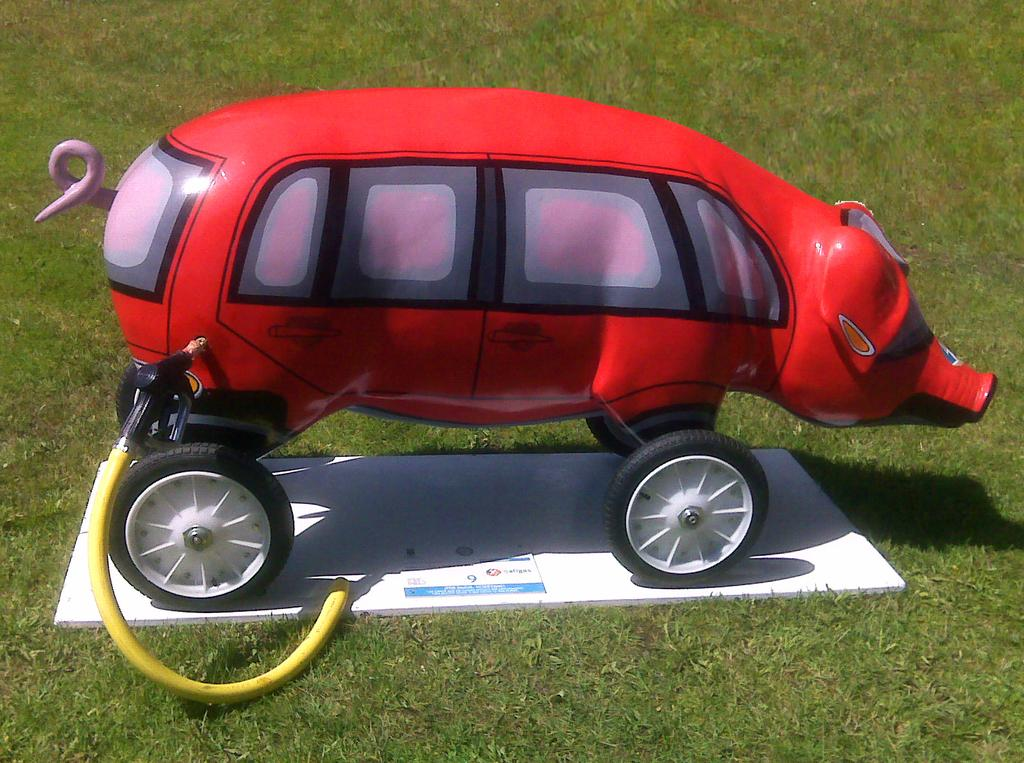What type of toy is in the image? There is a toy vehicle in the image. How is the toy vehicle stored or displayed? The toy vehicle is in a pig-shaped container. What is the container resting on? The pig-shaped container is on a wooden plank. Where is the wooden plank located? The wooden plank is on the grass. What is connected to the toy vehicle? There is a petrol pipe connected to the toy vehicle. What type of brass instrument is being played by the toy vehicle in the image? There is no brass instrument or any indication of music being played in the image. 